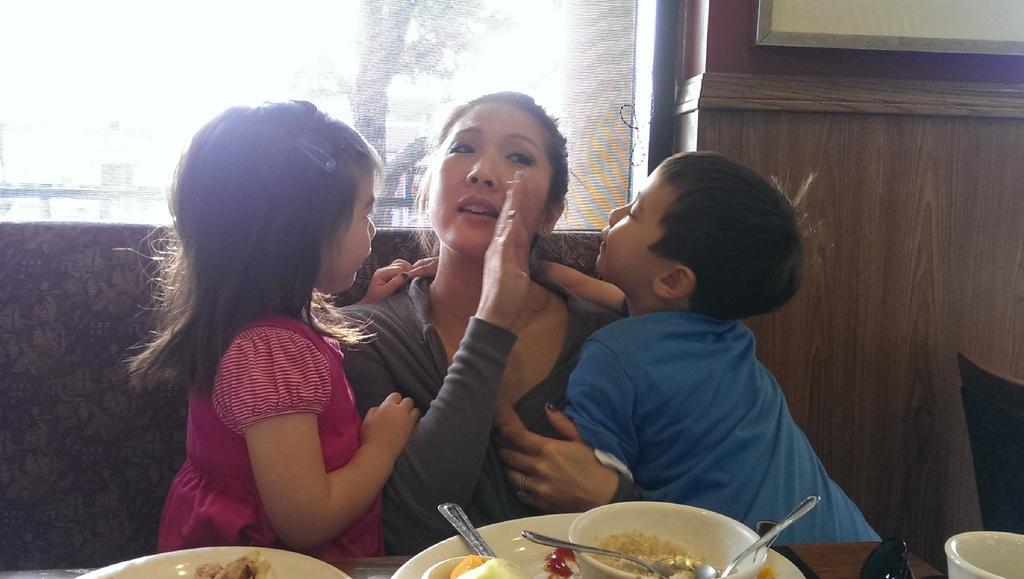Describe this image in one or two sentences. In this image there is a woman in the middle, who is sitting in the sofa. Beside the women there are two kids who are trying to kiss the woman. In front of her there is a table on which there are plates and bowls. In the bowls there is food and spoons. In the background there is a glass window. On the right side there is a wall in the background. On the right side bottom there is a chair. On the right side top there is a board. Through the glass window we can see the tree. 